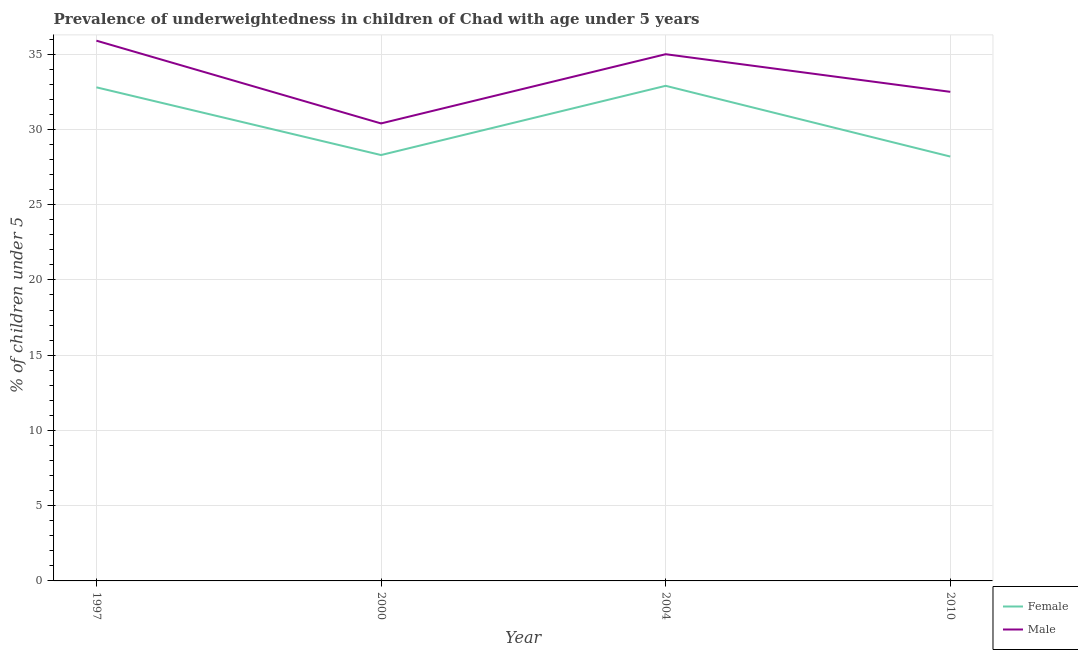How many different coloured lines are there?
Provide a short and direct response. 2. Does the line corresponding to percentage of underweighted male children intersect with the line corresponding to percentage of underweighted female children?
Your response must be concise. No. What is the percentage of underweighted female children in 1997?
Your answer should be very brief. 32.8. Across all years, what is the maximum percentage of underweighted male children?
Your answer should be compact. 35.9. Across all years, what is the minimum percentage of underweighted female children?
Give a very brief answer. 28.2. In which year was the percentage of underweighted female children maximum?
Your response must be concise. 2004. In which year was the percentage of underweighted female children minimum?
Keep it short and to the point. 2010. What is the total percentage of underweighted male children in the graph?
Offer a very short reply. 133.8. What is the difference between the percentage of underweighted male children in 2004 and that in 2010?
Offer a terse response. 2.5. What is the difference between the percentage of underweighted male children in 1997 and the percentage of underweighted female children in 2000?
Make the answer very short. 7.6. What is the average percentage of underweighted female children per year?
Make the answer very short. 30.55. In the year 2010, what is the difference between the percentage of underweighted male children and percentage of underweighted female children?
Keep it short and to the point. 4.3. What is the ratio of the percentage of underweighted female children in 2000 to that in 2004?
Offer a very short reply. 0.86. What is the difference between the highest and the second highest percentage of underweighted female children?
Make the answer very short. 0.1. What is the difference between the highest and the lowest percentage of underweighted male children?
Offer a very short reply. 5.5. Is the sum of the percentage of underweighted male children in 2000 and 2004 greater than the maximum percentage of underweighted female children across all years?
Make the answer very short. Yes. Is the percentage of underweighted male children strictly greater than the percentage of underweighted female children over the years?
Make the answer very short. Yes. How many lines are there?
Make the answer very short. 2. What is the difference between two consecutive major ticks on the Y-axis?
Keep it short and to the point. 5. Are the values on the major ticks of Y-axis written in scientific E-notation?
Your answer should be compact. No. Does the graph contain any zero values?
Make the answer very short. No. Does the graph contain grids?
Make the answer very short. Yes. Where does the legend appear in the graph?
Your answer should be compact. Bottom right. How many legend labels are there?
Your answer should be compact. 2. How are the legend labels stacked?
Offer a very short reply. Vertical. What is the title of the graph?
Offer a terse response. Prevalence of underweightedness in children of Chad with age under 5 years. What is the label or title of the X-axis?
Your response must be concise. Year. What is the label or title of the Y-axis?
Provide a short and direct response.  % of children under 5. What is the  % of children under 5 in Female in 1997?
Make the answer very short. 32.8. What is the  % of children under 5 of Male in 1997?
Offer a terse response. 35.9. What is the  % of children under 5 of Female in 2000?
Offer a terse response. 28.3. What is the  % of children under 5 in Male in 2000?
Make the answer very short. 30.4. What is the  % of children under 5 of Female in 2004?
Make the answer very short. 32.9. What is the  % of children under 5 in Female in 2010?
Keep it short and to the point. 28.2. What is the  % of children under 5 in Male in 2010?
Offer a very short reply. 32.5. Across all years, what is the maximum  % of children under 5 of Female?
Make the answer very short. 32.9. Across all years, what is the maximum  % of children under 5 in Male?
Give a very brief answer. 35.9. Across all years, what is the minimum  % of children under 5 in Female?
Make the answer very short. 28.2. Across all years, what is the minimum  % of children under 5 of Male?
Your answer should be very brief. 30.4. What is the total  % of children under 5 of Female in the graph?
Offer a very short reply. 122.2. What is the total  % of children under 5 in Male in the graph?
Offer a very short reply. 133.8. What is the difference between the  % of children under 5 in Male in 1997 and that in 2004?
Your answer should be compact. 0.9. What is the difference between the  % of children under 5 in Female in 1997 and that in 2010?
Make the answer very short. 4.6. What is the difference between the  % of children under 5 of Male in 1997 and that in 2010?
Your answer should be compact. 3.4. What is the difference between the  % of children under 5 in Female in 2000 and that in 2004?
Your answer should be very brief. -4.6. What is the difference between the  % of children under 5 in Male in 2004 and that in 2010?
Ensure brevity in your answer.  2.5. What is the average  % of children under 5 in Female per year?
Provide a short and direct response. 30.55. What is the average  % of children under 5 of Male per year?
Provide a short and direct response. 33.45. In the year 1997, what is the difference between the  % of children under 5 of Female and  % of children under 5 of Male?
Offer a terse response. -3.1. In the year 2000, what is the difference between the  % of children under 5 of Female and  % of children under 5 of Male?
Keep it short and to the point. -2.1. In the year 2004, what is the difference between the  % of children under 5 in Female and  % of children under 5 in Male?
Offer a terse response. -2.1. In the year 2010, what is the difference between the  % of children under 5 in Female and  % of children under 5 in Male?
Your response must be concise. -4.3. What is the ratio of the  % of children under 5 in Female in 1997 to that in 2000?
Provide a short and direct response. 1.16. What is the ratio of the  % of children under 5 in Male in 1997 to that in 2000?
Provide a succinct answer. 1.18. What is the ratio of the  % of children under 5 of Male in 1997 to that in 2004?
Provide a succinct answer. 1.03. What is the ratio of the  % of children under 5 in Female in 1997 to that in 2010?
Offer a very short reply. 1.16. What is the ratio of the  % of children under 5 in Male in 1997 to that in 2010?
Offer a very short reply. 1.1. What is the ratio of the  % of children under 5 in Female in 2000 to that in 2004?
Offer a terse response. 0.86. What is the ratio of the  % of children under 5 in Male in 2000 to that in 2004?
Provide a short and direct response. 0.87. What is the ratio of the  % of children under 5 of Male in 2000 to that in 2010?
Your response must be concise. 0.94. What is the ratio of the  % of children under 5 in Female in 2004 to that in 2010?
Give a very brief answer. 1.17. What is the ratio of the  % of children under 5 of Male in 2004 to that in 2010?
Ensure brevity in your answer.  1.08. What is the difference between the highest and the second highest  % of children under 5 in Female?
Provide a short and direct response. 0.1. What is the difference between the highest and the second highest  % of children under 5 in Male?
Provide a short and direct response. 0.9. What is the difference between the highest and the lowest  % of children under 5 in Female?
Provide a short and direct response. 4.7. 